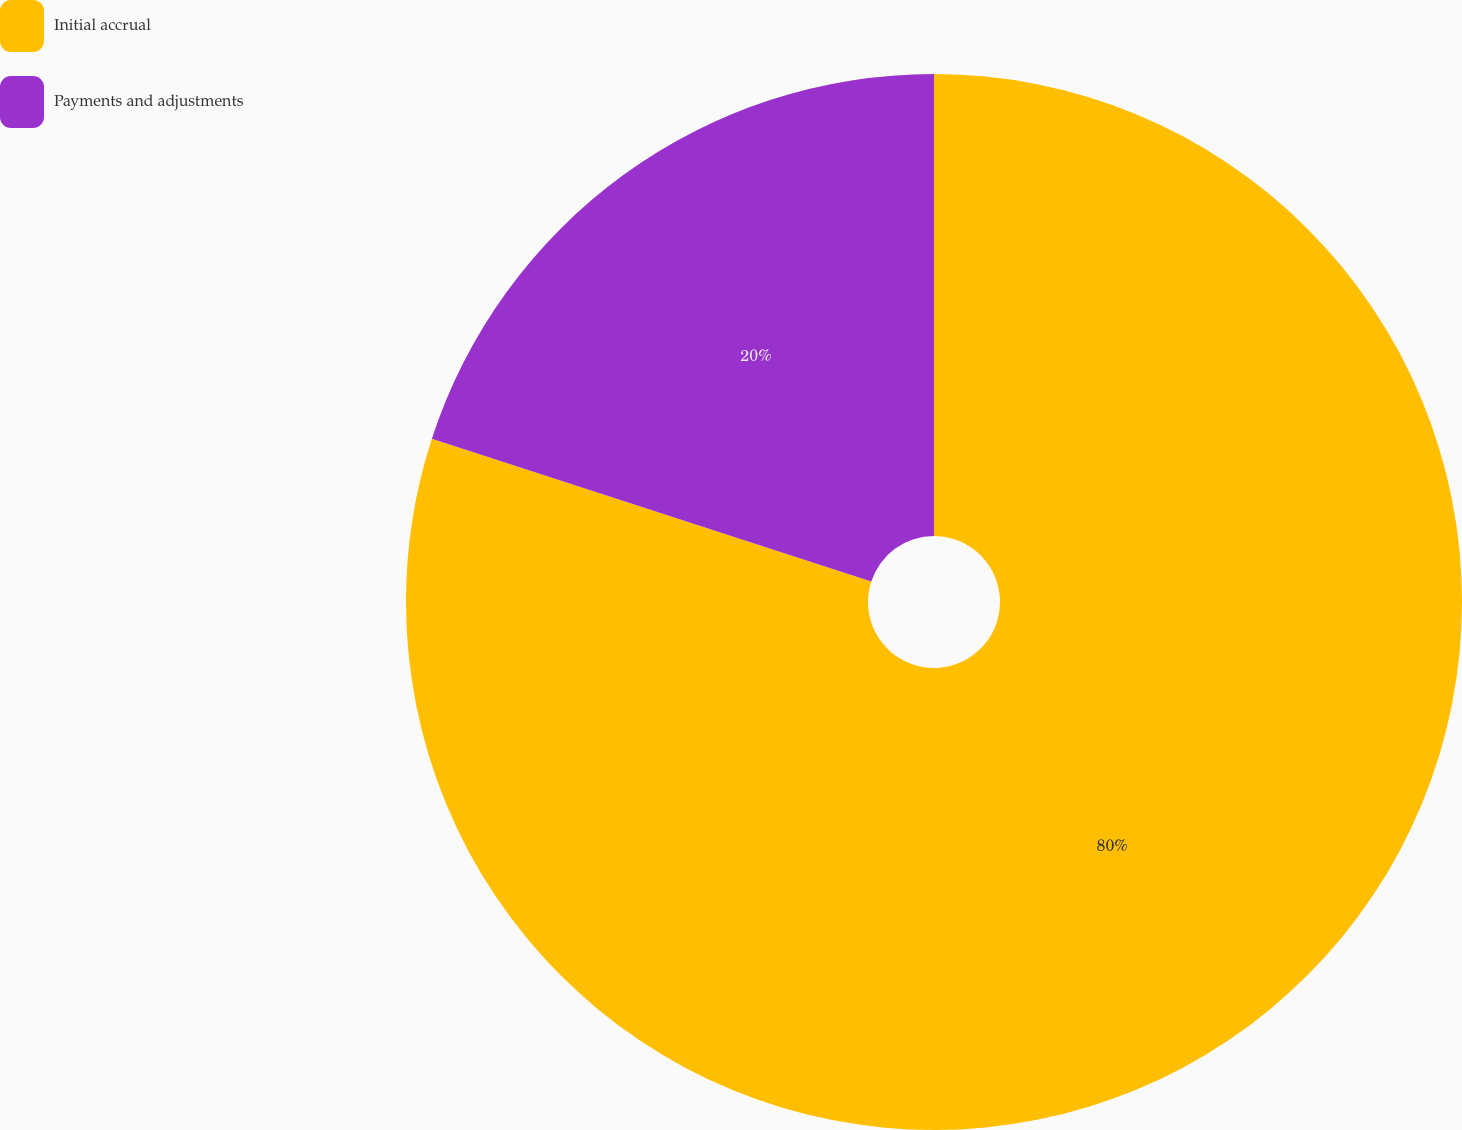Convert chart. <chart><loc_0><loc_0><loc_500><loc_500><pie_chart><fcel>Initial accrual<fcel>Payments and adjustments<nl><fcel>80.0%<fcel>20.0%<nl></chart> 